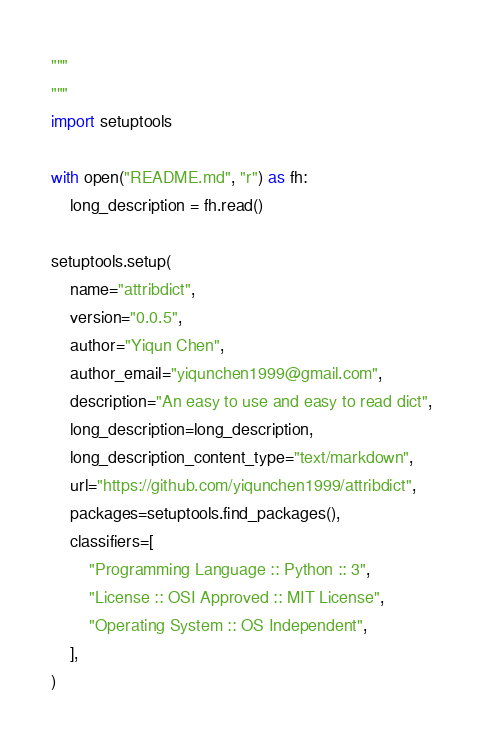Convert code to text. <code><loc_0><loc_0><loc_500><loc_500><_Python_>"""
"""
import setuptools

with open("README.md", "r") as fh:
    long_description = fh.read()

setuptools.setup(
    name="attribdict",
    version="0.0.5",
    author="Yiqun Chen",
    author_email="yiqunchen1999@gmail.com",
    description="An easy to use and easy to read dict",
    long_description=long_description,
    long_description_content_type="text/markdown",
    url="https://github.com/yiqunchen1999/attribdict",
    packages=setuptools.find_packages(),
    classifiers=[
        "Programming Language :: Python :: 3",
        "License :: OSI Approved :: MIT License",
        "Operating System :: OS Independent",
    ],
)</code> 